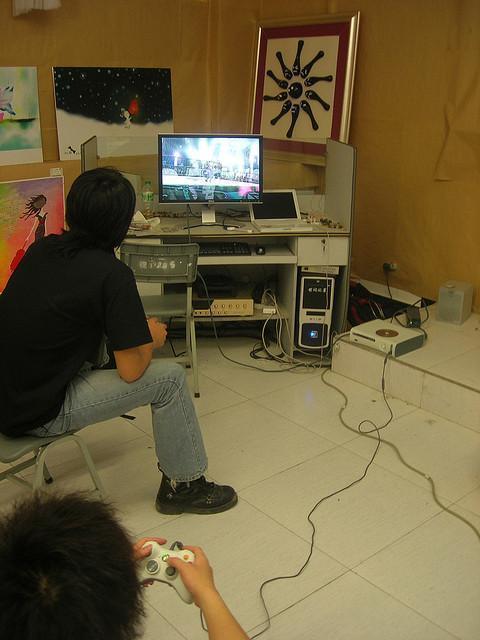What are the people playing?
Indicate the correct choice and explain in the format: 'Answer: answer
Rationale: rationale.'
Options: Basketball, tennis, video games, baseball. Answer: video games.
Rationale: Two people are playing a competitive game using a controller. 